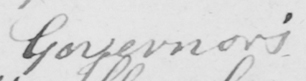Transcribe the text shown in this historical manuscript line. Governor ' s 